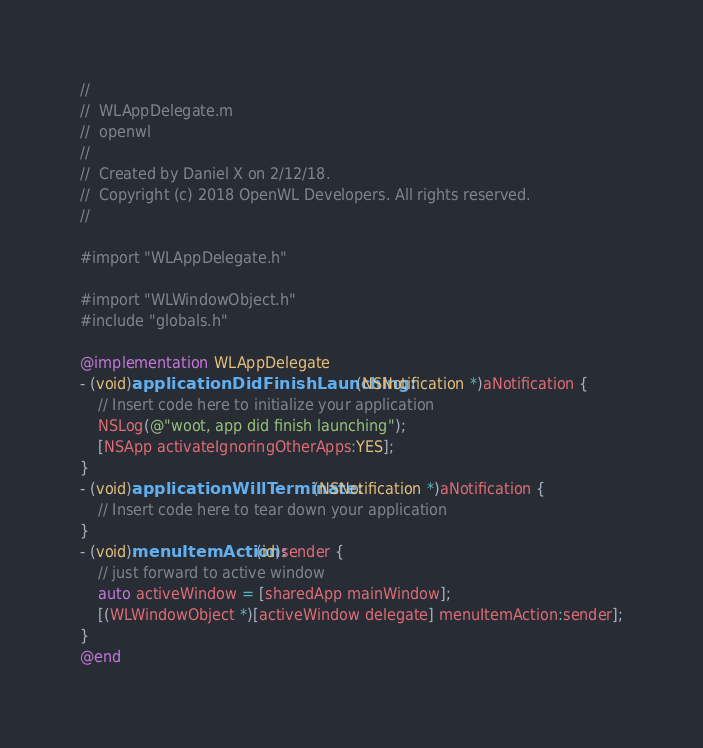Convert code to text. <code><loc_0><loc_0><loc_500><loc_500><_ObjectiveC_>//
//  WLAppDelegate.m
//  openwl
//
//  Created by Daniel X on 2/12/18.
//  Copyright (c) 2018 OpenWL Developers. All rights reserved.
//

#import "WLAppDelegate.h"

#import "WLWindowObject.h"
#include "globals.h"

@implementation WLAppDelegate
- (void)applicationDidFinishLaunching:(NSNotification *)aNotification {
    // Insert code here to initialize your application
    NSLog(@"woot, app did finish launching");
    [NSApp activateIgnoringOtherApps:YES];
}
- (void)applicationWillTerminate:(NSNotification *)aNotification {
    // Insert code here to tear down your application
}
- (void)menuItemAction:(id)sender {
    // just forward to active window
    auto activeWindow = [sharedApp mainWindow];
    [(WLWindowObject *)[activeWindow delegate] menuItemAction:sender];
}
@end
</code> 